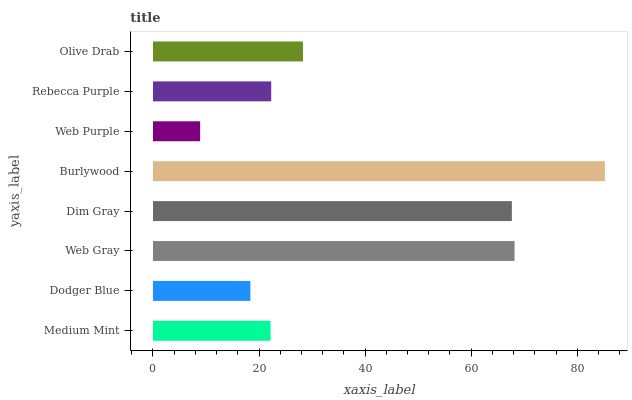Is Web Purple the minimum?
Answer yes or no. Yes. Is Burlywood the maximum?
Answer yes or no. Yes. Is Dodger Blue the minimum?
Answer yes or no. No. Is Dodger Blue the maximum?
Answer yes or no. No. Is Medium Mint greater than Dodger Blue?
Answer yes or no. Yes. Is Dodger Blue less than Medium Mint?
Answer yes or no. Yes. Is Dodger Blue greater than Medium Mint?
Answer yes or no. No. Is Medium Mint less than Dodger Blue?
Answer yes or no. No. Is Olive Drab the high median?
Answer yes or no. Yes. Is Rebecca Purple the low median?
Answer yes or no. Yes. Is Dodger Blue the high median?
Answer yes or no. No. Is Olive Drab the low median?
Answer yes or no. No. 